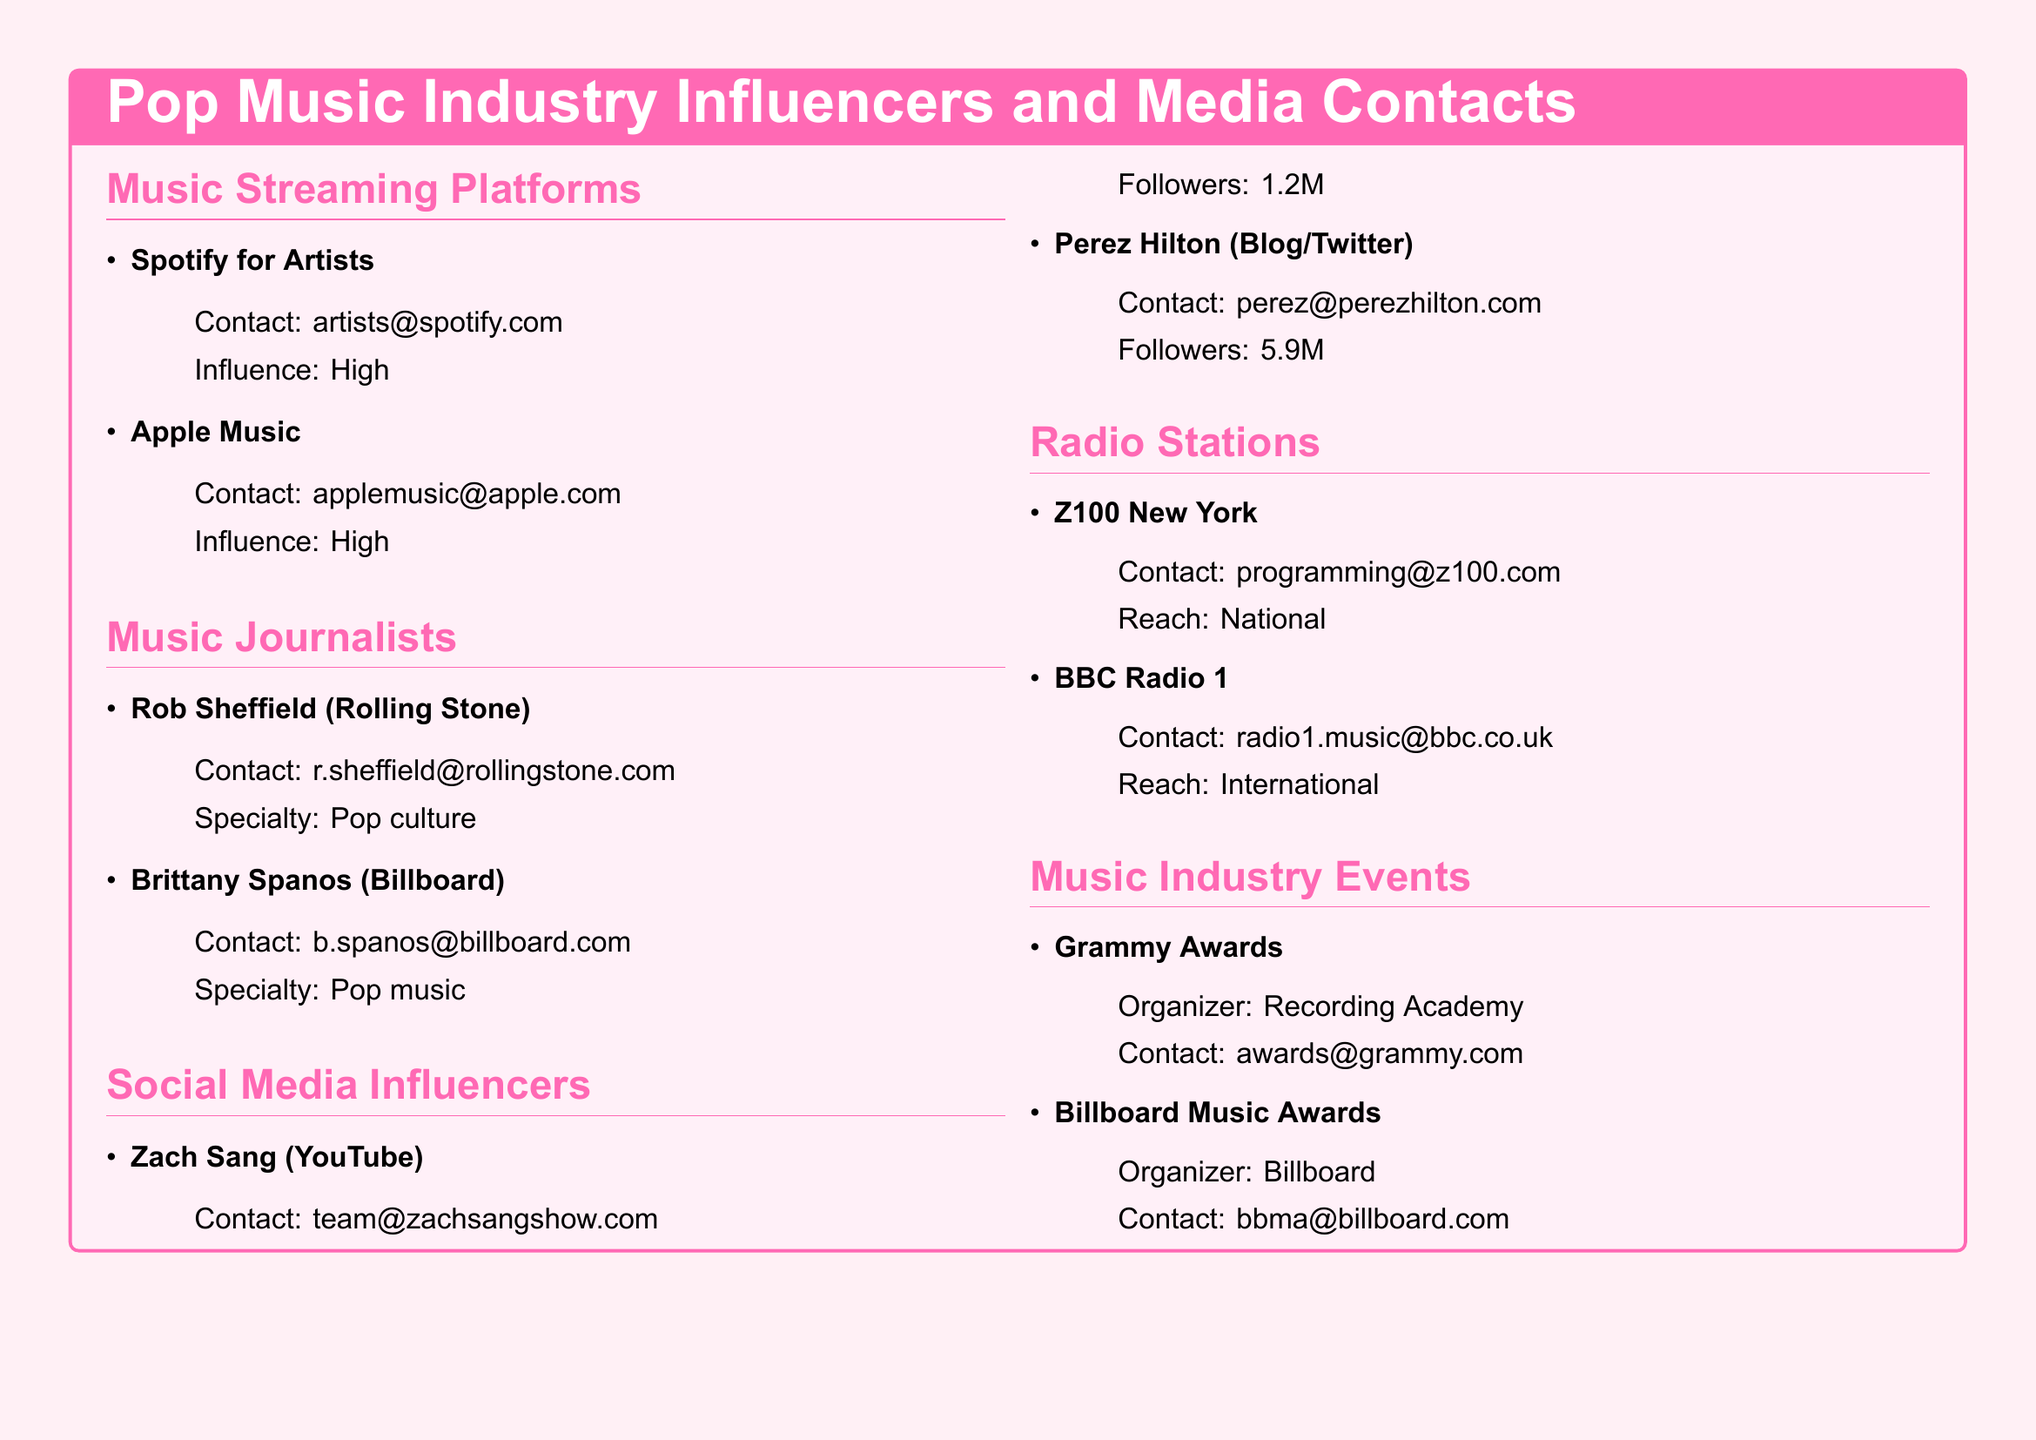what is the contact email for Spotify for Artists? The contact email for Spotify for Artists is mentioned in the document.
Answer: artists@spotify.com who is the music journalist at Billboard? The document lists Brittany Spanos as the music journalist at Billboard.
Answer: Brittany Spanos what is the reach of Z100 New York? The reach of Z100 New York is specified in the document.
Answer: National how many followers does Perez Hilton have? The document states that Perez Hilton has a specific number of followers.
Answer: 5.9M which organization is responsible for the Grammy Awards? The document identifies the organizer of the Grammy Awards.
Answer: Recording Academy what specialty does Rob Sheffield focus on? The document specifies Rob Sheffield's specialty in music journalism.
Answer: Pop culture how many music streaming platforms are listed in the document? By counting the sections in the document, the total number of music streaming platforms is determined.
Answer: 2 which social media platform does Zach Sang primarily use? The document indicates the platform associated with Zach Sang.
Answer: YouTube what is the contact email for the Billboard Music Awards? The document provides the contact email for the Billboard Music Awards organizer.
Answer: bbma@billboard.com 